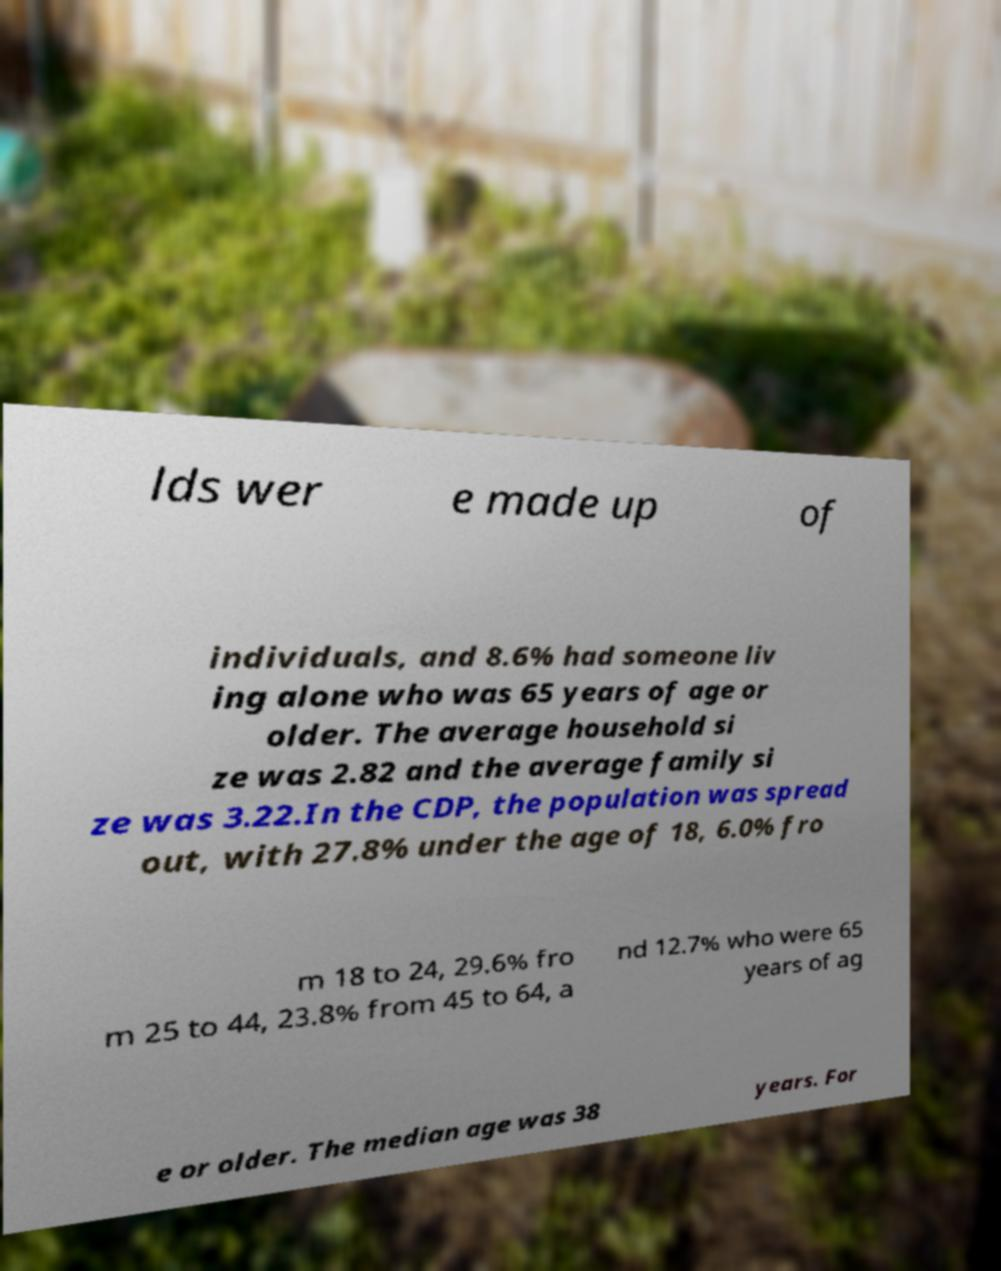I need the written content from this picture converted into text. Can you do that? lds wer e made up of individuals, and 8.6% had someone liv ing alone who was 65 years of age or older. The average household si ze was 2.82 and the average family si ze was 3.22.In the CDP, the population was spread out, with 27.8% under the age of 18, 6.0% fro m 18 to 24, 29.6% fro m 25 to 44, 23.8% from 45 to 64, a nd 12.7% who were 65 years of ag e or older. The median age was 38 years. For 